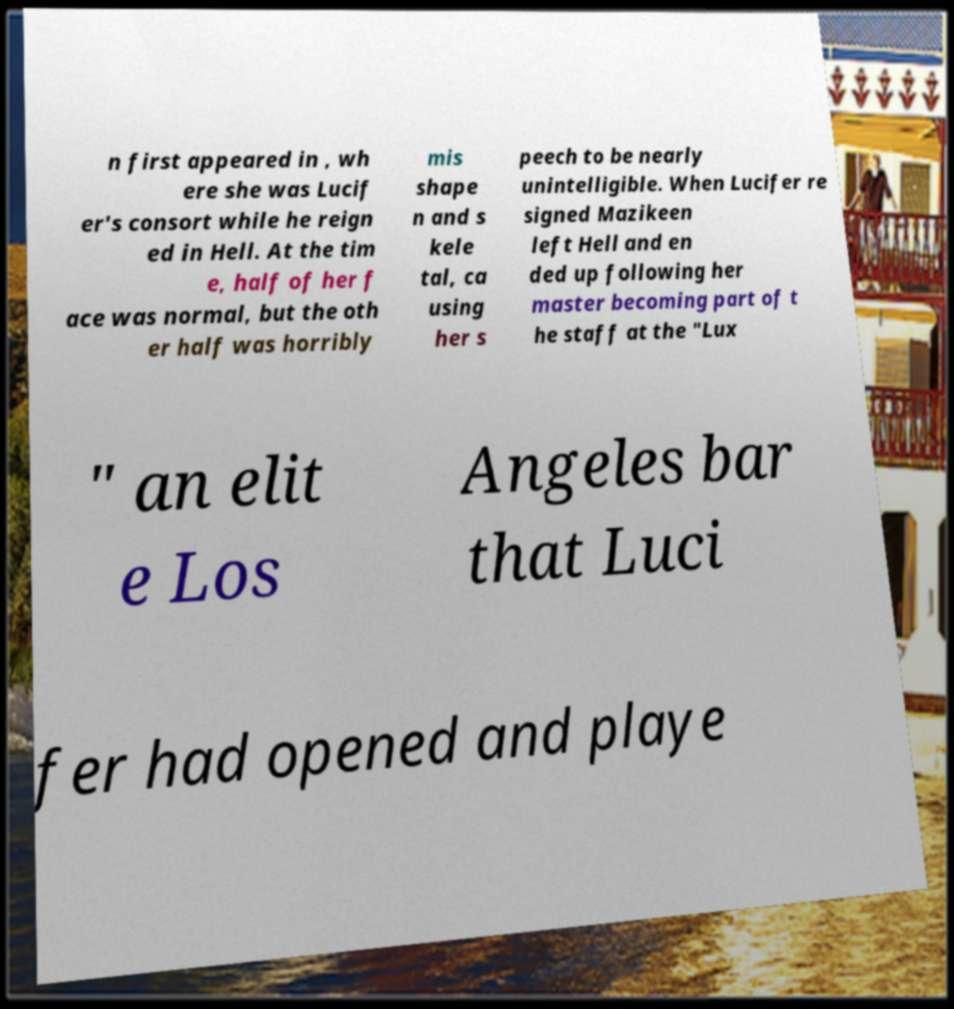I need the written content from this picture converted into text. Can you do that? n first appeared in , wh ere she was Lucif er's consort while he reign ed in Hell. At the tim e, half of her f ace was normal, but the oth er half was horribly mis shape n and s kele tal, ca using her s peech to be nearly unintelligible. When Lucifer re signed Mazikeen left Hell and en ded up following her master becoming part of t he staff at the "Lux " an elit e Los Angeles bar that Luci fer had opened and playe 